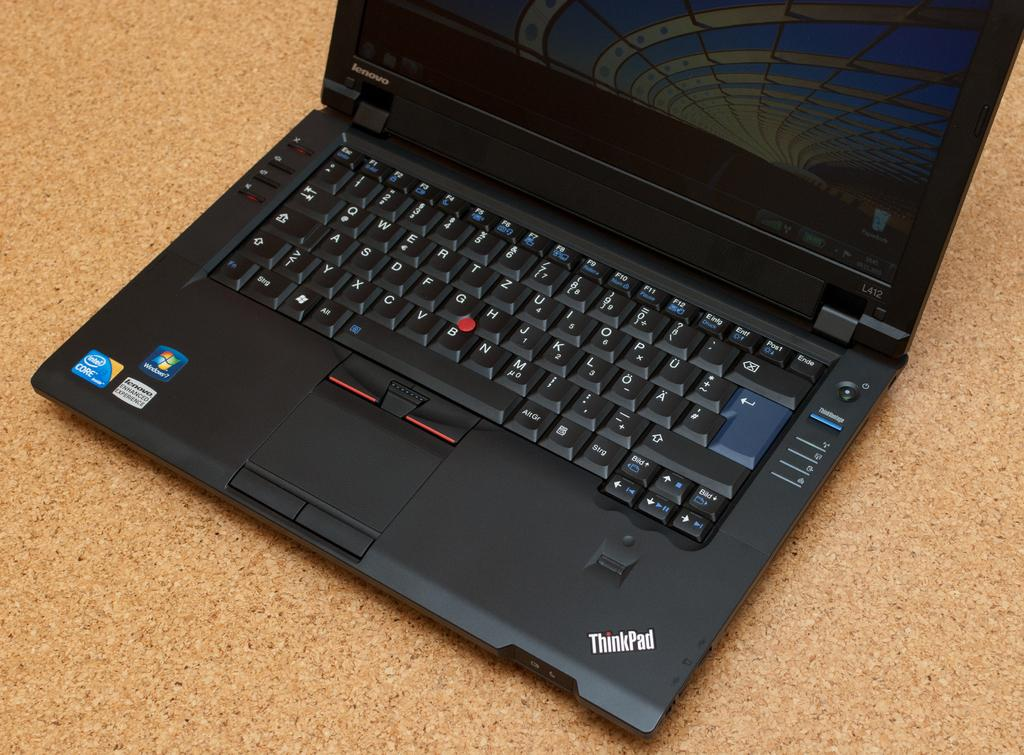What electronic device is visible in the picture? There is a laptop in the picture. What is the laptop placed on? The laptop is on a cream-colored surface. What is the color of the laptop? The laptop is black in color. What scent is emanating from the laptop in the image? There is no indication of a scent in the image, as laptops do not emit scents. 